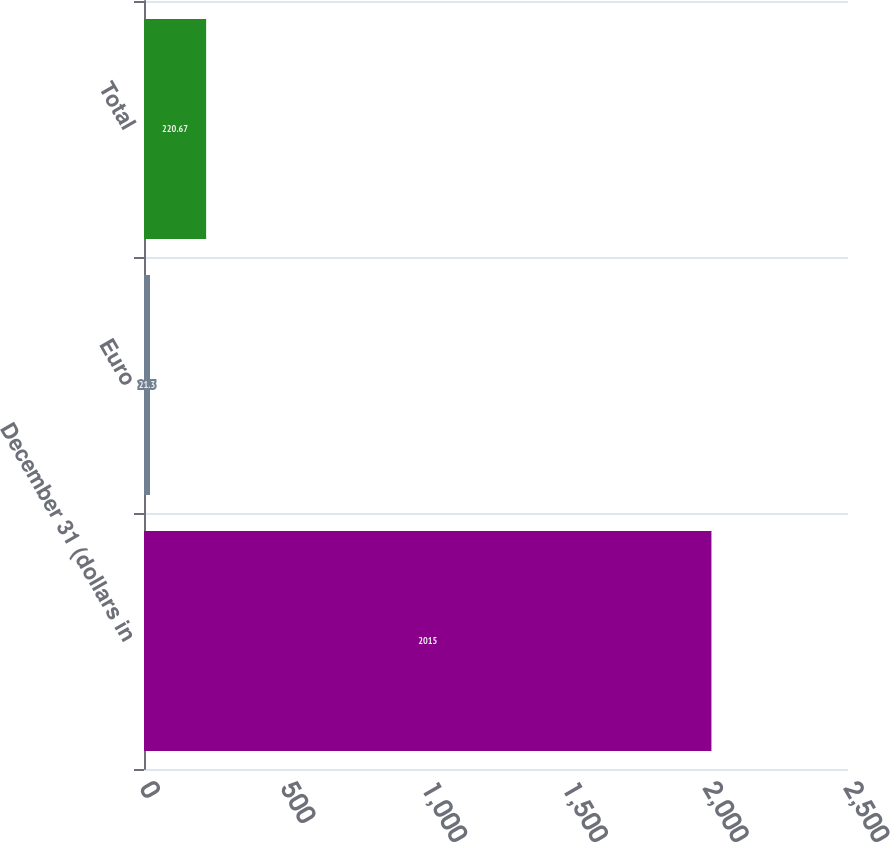<chart> <loc_0><loc_0><loc_500><loc_500><bar_chart><fcel>December 31 (dollars in<fcel>Euro<fcel>Total<nl><fcel>2015<fcel>21.3<fcel>220.67<nl></chart> 